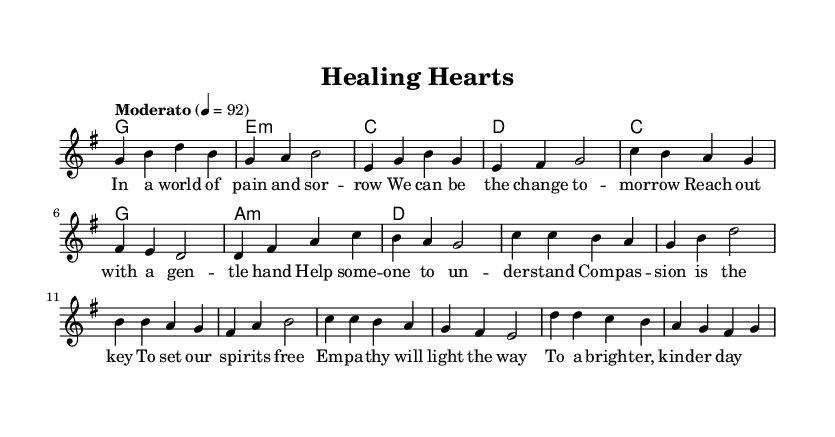What is the key signature of this music? The key signature is G major, which contains one sharp (F#).
Answer: G major What is the time signature of this piece? The time signature is 4/4, indicating four beats per measure.
Answer: 4/4 What is the tempo marking for this piece? The tempo marking is "Moderato," which means moderate speed.
Answer: Moderato How many measures are in the verse? There are eight measures in the verse, as counted from the melody section until the end of it.
Answer: Eight Which chord follows the first line of the chorus? The chord following the first line of the chorus is C major, as indicated in the harmonies section.
Answer: C What is the primary theme explored in this acoustic rock ballad? The primary theme is empathy and compassion, as reflected in both the lyrics and the overall intent of the piece.
Answer: Empathy and compassion How does the melody change during the chorus compared to the verse? The melody in the chorus incorporates repeated notes and has a more uplifting contour, contrasting with the smoother line in the verse.
Answer: It becomes more uplifting 